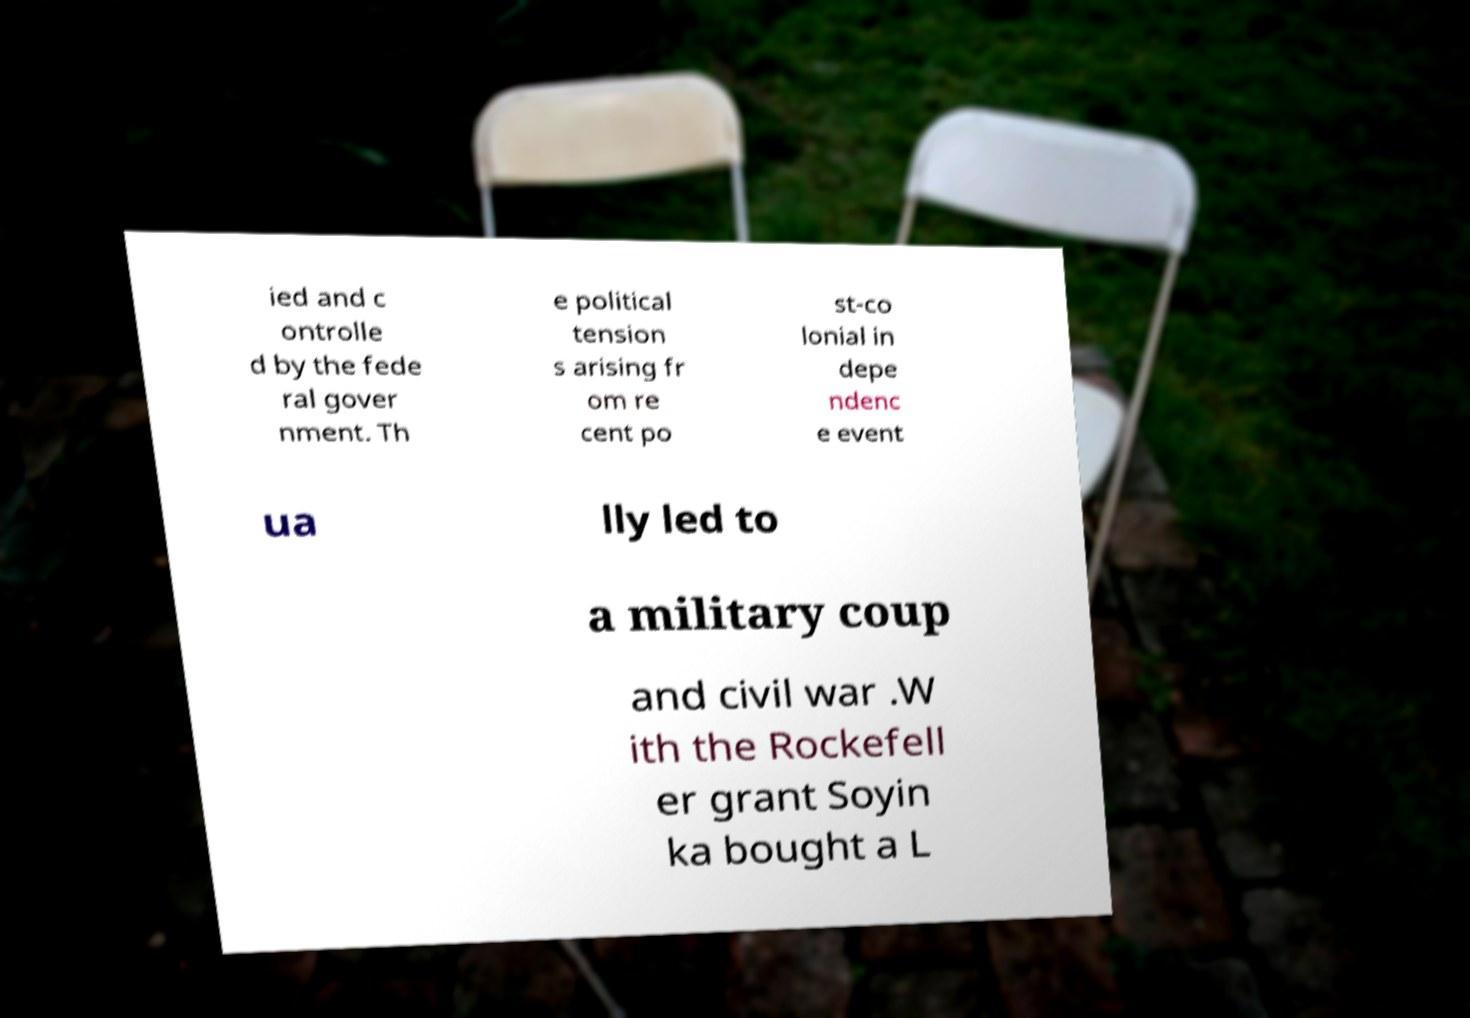Can you accurately transcribe the text from the provided image for me? ied and c ontrolle d by the fede ral gover nment. Th e political tension s arising fr om re cent po st-co lonial in depe ndenc e event ua lly led to a military coup and civil war .W ith the Rockefell er grant Soyin ka bought a L 